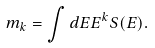Convert formula to latex. <formula><loc_0><loc_0><loc_500><loc_500>m _ { k } = \int d E E ^ { k } S ( E ) .</formula> 